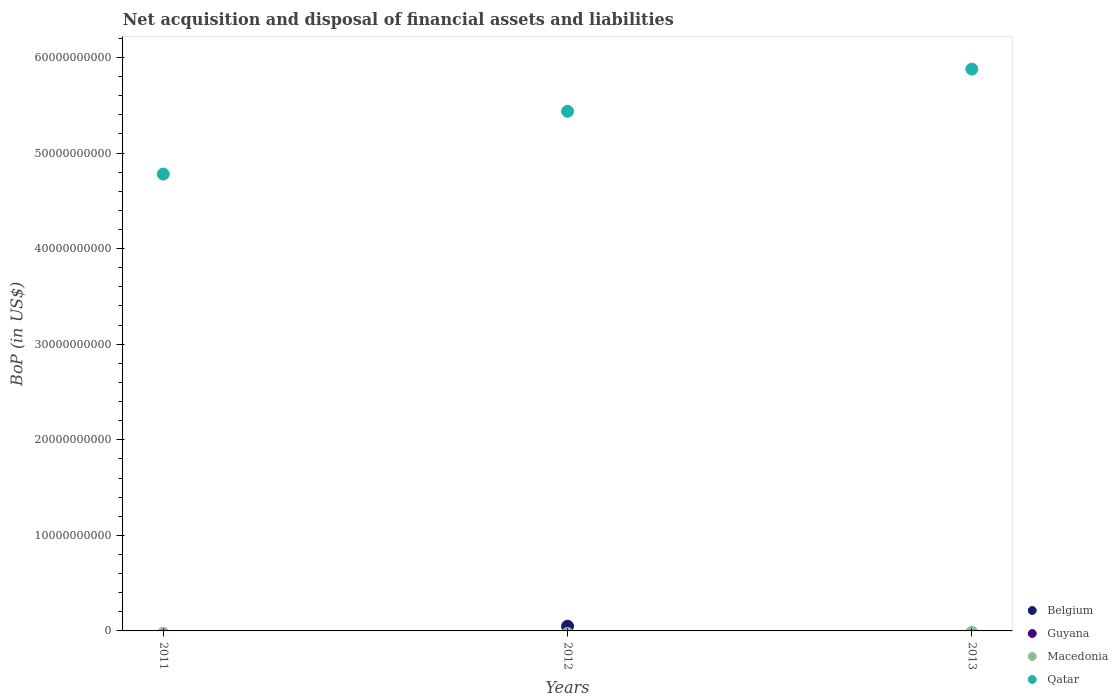Is the number of dotlines equal to the number of legend labels?
Offer a very short reply. No. What is the Balance of Payments in Guyana in 2013?
Provide a short and direct response. 0. Across all years, what is the maximum Balance of Payments in Belgium?
Offer a very short reply. 4.92e+08. What is the total Balance of Payments in Belgium in the graph?
Ensure brevity in your answer.  4.92e+08. What is the difference between the Balance of Payments in Qatar in 2012 and that in 2013?
Ensure brevity in your answer.  -4.41e+09. What is the difference between the Balance of Payments in Qatar in 2011 and the Balance of Payments in Macedonia in 2013?
Make the answer very short. 4.78e+1. What is the average Balance of Payments in Qatar per year?
Make the answer very short. 5.36e+1. In the year 2012, what is the difference between the Balance of Payments in Belgium and Balance of Payments in Qatar?
Offer a very short reply. -5.39e+1. What is the difference between the highest and the second highest Balance of Payments in Qatar?
Give a very brief answer. 4.41e+09. What is the difference between the highest and the lowest Balance of Payments in Belgium?
Give a very brief answer. 4.92e+08. In how many years, is the Balance of Payments in Guyana greater than the average Balance of Payments in Guyana taken over all years?
Your response must be concise. 0. Is it the case that in every year, the sum of the Balance of Payments in Belgium and Balance of Payments in Macedonia  is greater than the sum of Balance of Payments in Guyana and Balance of Payments in Qatar?
Offer a very short reply. No. Does the Balance of Payments in Macedonia monotonically increase over the years?
Your answer should be compact. No. How many dotlines are there?
Offer a terse response. 2. What is the difference between two consecutive major ticks on the Y-axis?
Your response must be concise. 1.00e+1. How many legend labels are there?
Offer a terse response. 4. What is the title of the graph?
Provide a short and direct response. Net acquisition and disposal of financial assets and liabilities. What is the label or title of the Y-axis?
Your answer should be very brief. BoP (in US$). What is the BoP (in US$) of Qatar in 2011?
Provide a short and direct response. 4.78e+1. What is the BoP (in US$) in Belgium in 2012?
Your answer should be compact. 4.92e+08. What is the BoP (in US$) in Qatar in 2012?
Provide a short and direct response. 5.44e+1. What is the BoP (in US$) in Belgium in 2013?
Your response must be concise. 0. What is the BoP (in US$) of Qatar in 2013?
Your response must be concise. 5.88e+1. Across all years, what is the maximum BoP (in US$) in Belgium?
Provide a short and direct response. 4.92e+08. Across all years, what is the maximum BoP (in US$) of Qatar?
Give a very brief answer. 5.88e+1. Across all years, what is the minimum BoP (in US$) in Belgium?
Offer a very short reply. 0. Across all years, what is the minimum BoP (in US$) of Qatar?
Your answer should be very brief. 4.78e+1. What is the total BoP (in US$) of Belgium in the graph?
Offer a very short reply. 4.92e+08. What is the total BoP (in US$) in Guyana in the graph?
Ensure brevity in your answer.  0. What is the total BoP (in US$) in Qatar in the graph?
Your response must be concise. 1.61e+11. What is the difference between the BoP (in US$) of Qatar in 2011 and that in 2012?
Your response must be concise. -6.57e+09. What is the difference between the BoP (in US$) of Qatar in 2011 and that in 2013?
Keep it short and to the point. -1.10e+1. What is the difference between the BoP (in US$) of Qatar in 2012 and that in 2013?
Keep it short and to the point. -4.41e+09. What is the difference between the BoP (in US$) in Belgium in 2012 and the BoP (in US$) in Qatar in 2013?
Your answer should be compact. -5.83e+1. What is the average BoP (in US$) in Belgium per year?
Make the answer very short. 1.64e+08. What is the average BoP (in US$) of Macedonia per year?
Make the answer very short. 0. What is the average BoP (in US$) in Qatar per year?
Offer a terse response. 5.36e+1. In the year 2012, what is the difference between the BoP (in US$) of Belgium and BoP (in US$) of Qatar?
Make the answer very short. -5.39e+1. What is the ratio of the BoP (in US$) of Qatar in 2011 to that in 2012?
Your answer should be very brief. 0.88. What is the ratio of the BoP (in US$) in Qatar in 2011 to that in 2013?
Ensure brevity in your answer.  0.81. What is the ratio of the BoP (in US$) in Qatar in 2012 to that in 2013?
Your answer should be compact. 0.92. What is the difference between the highest and the second highest BoP (in US$) in Qatar?
Your answer should be compact. 4.41e+09. What is the difference between the highest and the lowest BoP (in US$) in Belgium?
Provide a short and direct response. 4.92e+08. What is the difference between the highest and the lowest BoP (in US$) in Qatar?
Provide a short and direct response. 1.10e+1. 